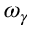<formula> <loc_0><loc_0><loc_500><loc_500>\omega _ { \gamma }</formula> 